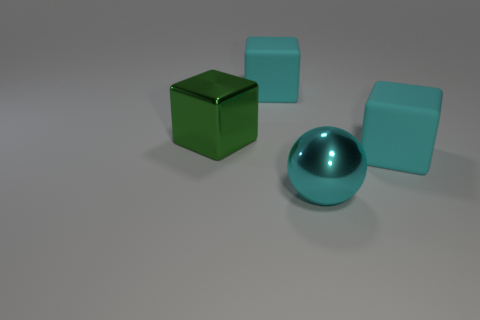Do the green metallic thing and the large rubber thing that is left of the large cyan sphere have the same shape?
Keep it short and to the point. Yes. How many cubes have the same size as the cyan ball?
Provide a short and direct response. 3. There is a cyan rubber thing right of the cyan metal object; is its shape the same as the metallic object that is left of the big metal ball?
Your answer should be very brief. Yes. There is a matte thing left of the rubber thing that is on the right side of the cyan shiny object; what is its color?
Offer a terse response. Cyan. Is there anything else that is the same material as the cyan ball?
Your answer should be compact. Yes. What is the large cyan block behind the shiny block made of?
Your answer should be compact. Rubber. Are there fewer large metallic blocks in front of the large cyan metal ball than big cyan metal balls?
Make the answer very short. Yes. There is a object in front of the large cube to the right of the cyan ball; what shape is it?
Your response must be concise. Sphere. What color is the metal cube?
Provide a short and direct response. Green. How many other objects are the same size as the metal block?
Give a very brief answer. 3. 